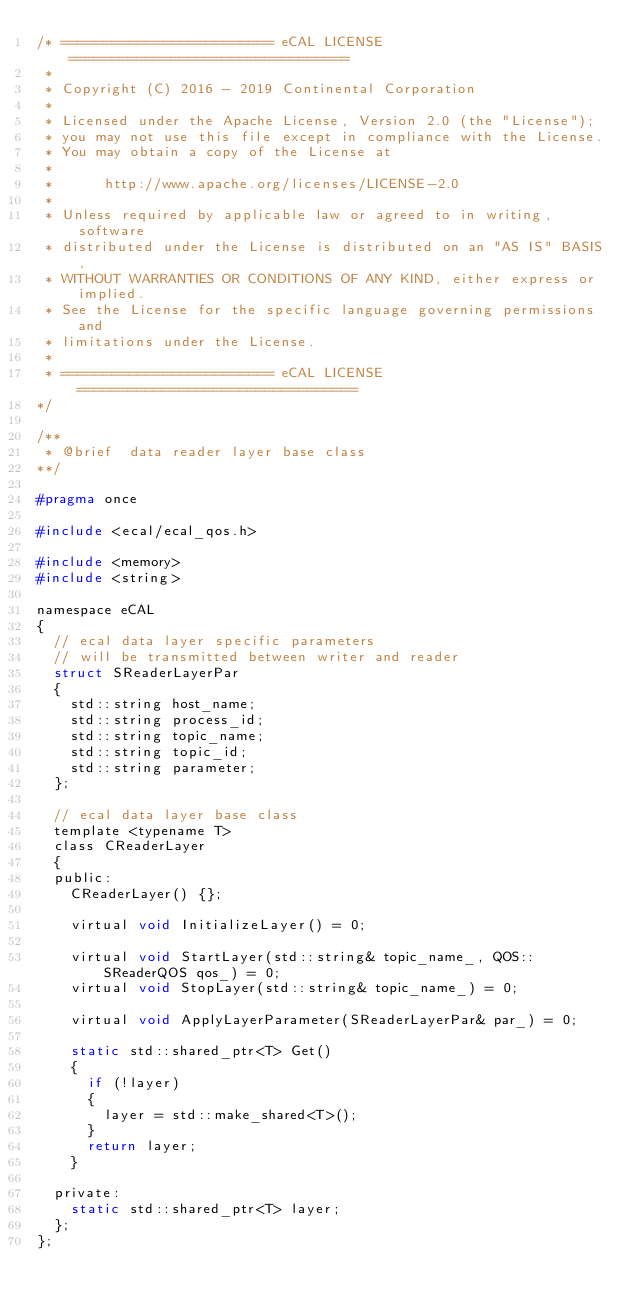Convert code to text. <code><loc_0><loc_0><loc_500><loc_500><_C_>/* ========================= eCAL LICENSE =================================
 *
 * Copyright (C) 2016 - 2019 Continental Corporation
 *
 * Licensed under the Apache License, Version 2.0 (the "License");
 * you may not use this file except in compliance with the License.
 * You may obtain a copy of the License at
 * 
 *      http://www.apache.org/licenses/LICENSE-2.0
 * 
 * Unless required by applicable law or agreed to in writing, software
 * distributed under the License is distributed on an "AS IS" BASIS,
 * WITHOUT WARRANTIES OR CONDITIONS OF ANY KIND, either express or implied.
 * See the License for the specific language governing permissions and
 * limitations under the License.
 *
 * ========================= eCAL LICENSE =================================
*/

/**
 * @brief  data reader layer base class
**/

#pragma once

#include <ecal/ecal_qos.h>

#include <memory>
#include <string>

namespace eCAL
{
  // ecal data layer specific parameters
  // will be transmitted between writer and reader
  struct SReaderLayerPar
  {
    std::string host_name;
    std::string process_id;
    std::string topic_name;
    std::string topic_id;
    std::string parameter;
  };

  // ecal data layer base class
  template <typename T>
  class CReaderLayer
  {
  public:
    CReaderLayer() {};

    virtual void InitializeLayer() = 0;

    virtual void StartLayer(std::string& topic_name_, QOS::SReaderQOS qos_) = 0;
    virtual void StopLayer(std::string& topic_name_) = 0;

    virtual void ApplyLayerParameter(SReaderLayerPar& par_) = 0;

    static std::shared_ptr<T> Get()
    {
      if (!layer)
      {
        layer = std::make_shared<T>();
      }
      return layer;
    }

  private:
    static std::shared_ptr<T> layer;
  };
};
</code> 